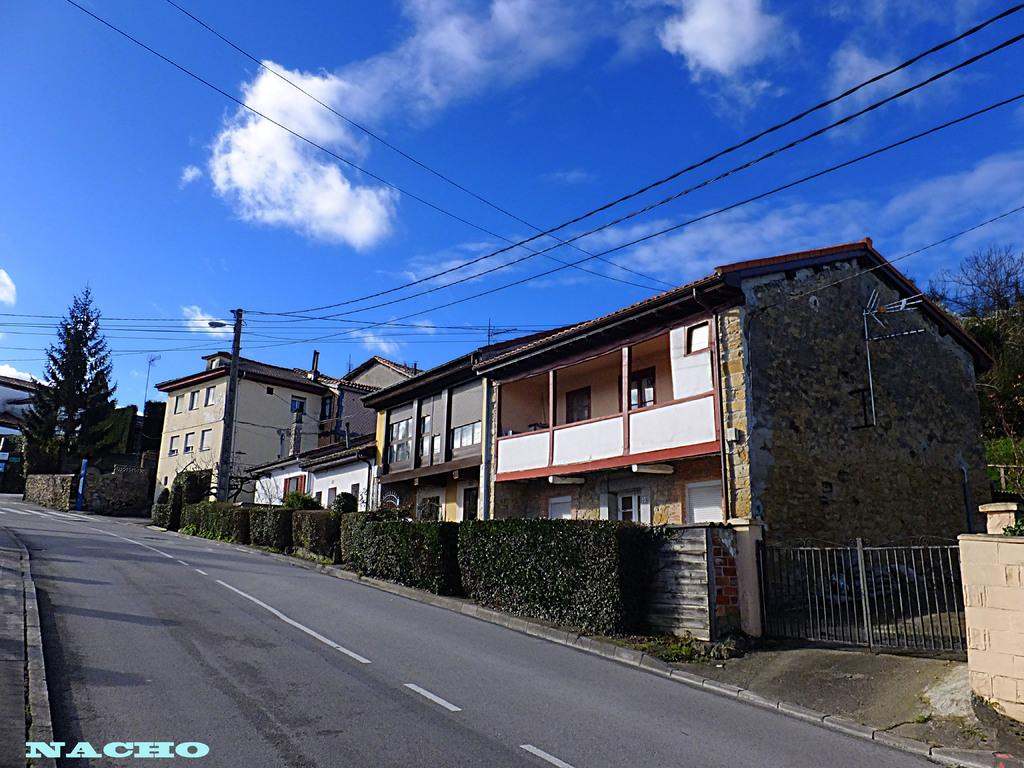Provide a one-sentence caption for the provided image. The house and street photo was taken by Nacho. 